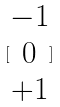Convert formula to latex. <formula><loc_0><loc_0><loc_500><loc_500>[ \begin{matrix} - 1 \\ 0 \\ + 1 \end{matrix} ]</formula> 